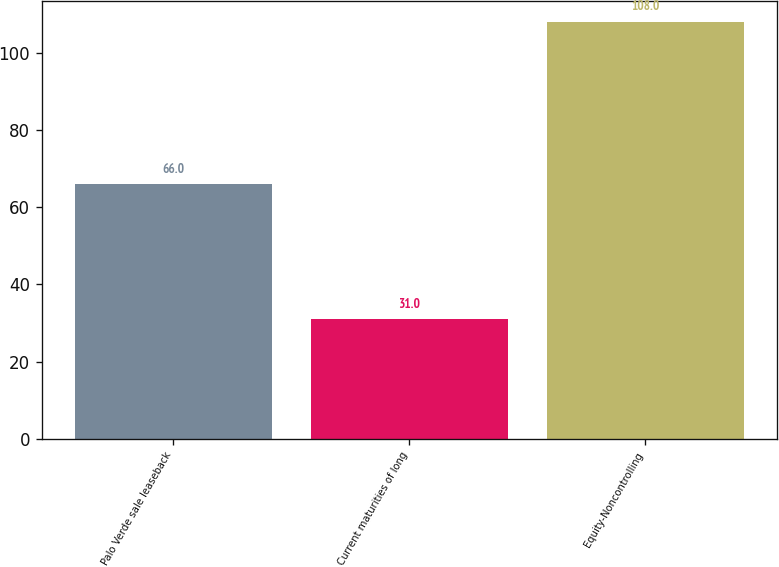Convert chart to OTSL. <chart><loc_0><loc_0><loc_500><loc_500><bar_chart><fcel>Palo Verde sale leaseback<fcel>Current maturities of long<fcel>Equity-Noncontrolling<nl><fcel>66<fcel>31<fcel>108<nl></chart> 